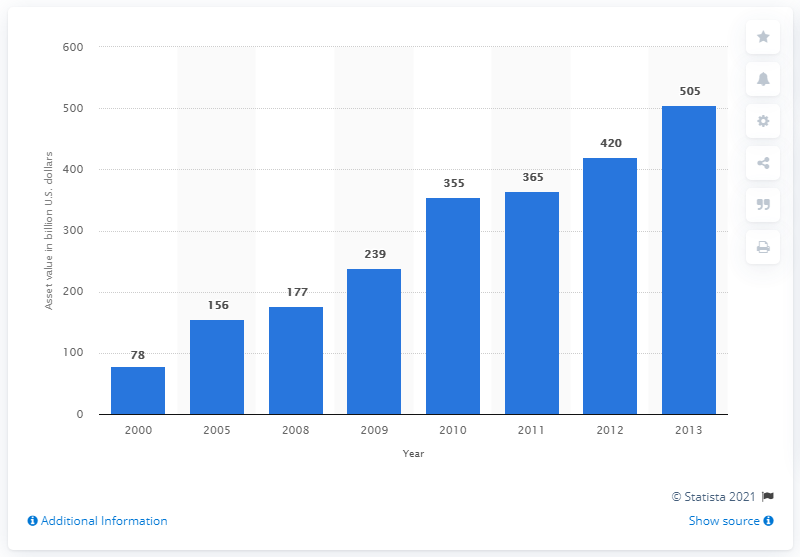Indicate a few pertinent items in this graphic. In 2013, the value of Roth IRAs was $505. 